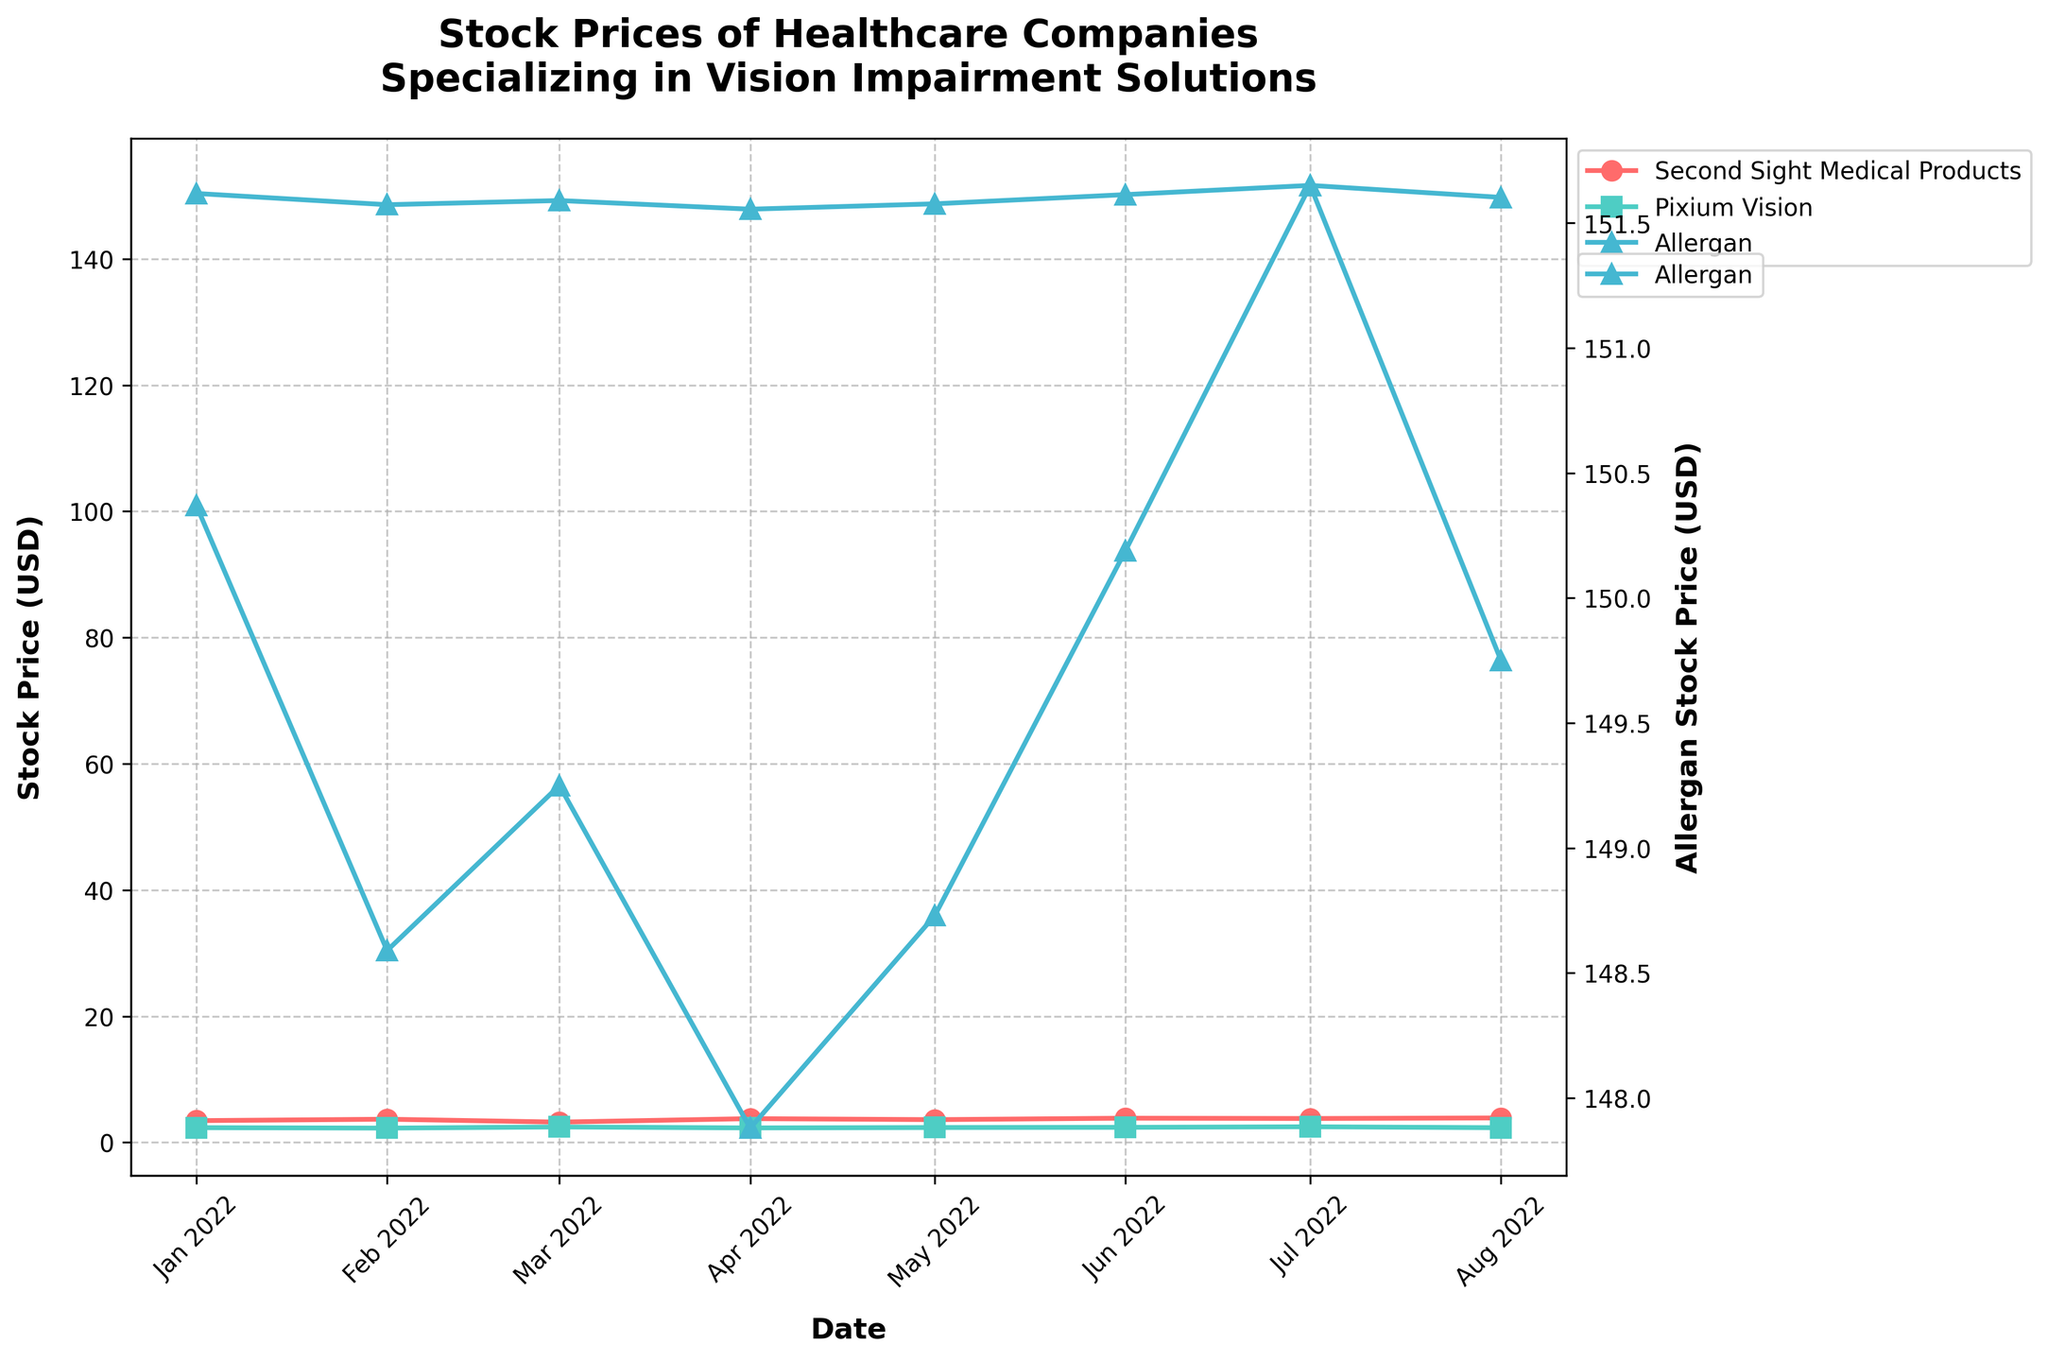What is the title of the figure? The title of the figure is typically displayed prominently at the top. In this case, it states what the plot is about.
Answer: Stock Prices of Healthcare Companies Specializing in Vision Impairment Solutions Which company had the highest stock price in January 2022? To find this, I locate the stock prices for January 2022 for all the companies and compare them.
Answer: Allergan How did the stock price of Second Sight Medical Products change between January 2022 and August 2022? To answer this, I observe the stock price of this company at both dates and compare the values to describe the change.
Answer: It increased from 3.45 USD to 3.88 USD Which company experienced a dip in their stock price in February 2022 compared to the previous month? By comparing the stock prices of each company in January 2022 and February 2022, I look for a company whose stock price decreased.
Answer: Pixium Vision What was the general trend of Allergan's stock price over the months shown in the plot? Observing the stock prices of Allergan across multiple months, I identify whether the prices are increasing, decreasing or fluctuating.
Answer: Fluctuating with slight overall decrease Between June 2022 and July 2022, which company had the most significant increase in stock price? By comparing the stock prices of each company between June 2022 and July 2022, I identify which company had the largest positive change in value.
Answer: Pixium Vision Which company had the most stable stock price from January 2022 to August 2022? By comparing the stock price fluctuations of each company over the months, I determine which company had the least variation.
Answer: Pixium Vision What was the stock price of Second Sight Medical Products in March 2022? I locate the stock price for Second Sight Medical Products in the data point for March 2022.
Answer: 3.22 USD How does the stock price trend of Pixium Vision compare to that of Second Sight Medical Products over the given period? By observing the stock price trends of both companies, I compare whether they move similarly, diverge, or show different patterns.
Answer: Pixium Vision's is relatively more stable; Second Sight Medical Products shows more fluctuations Did Second Sight Medical Products' stock price reach its highest value in August 2022 according to the plot? Reviewing the monthly stock prices for Second Sight Medical Products, I identify whether August 2022 marks the highest recorded value.
Answer: Yes 